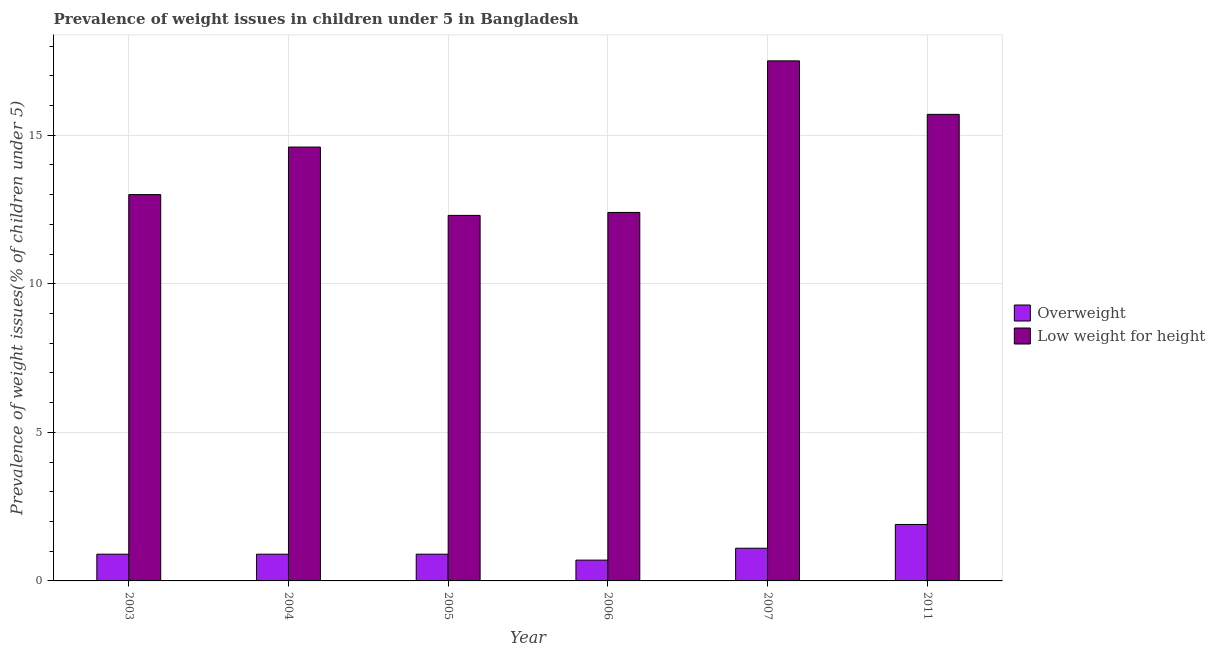How many groups of bars are there?
Offer a terse response. 6. Are the number of bars per tick equal to the number of legend labels?
Ensure brevity in your answer.  Yes. Are the number of bars on each tick of the X-axis equal?
Give a very brief answer. Yes. How many bars are there on the 4th tick from the right?
Your answer should be compact. 2. What is the label of the 2nd group of bars from the left?
Your response must be concise. 2004. In how many cases, is the number of bars for a given year not equal to the number of legend labels?
Provide a succinct answer. 0. What is the percentage of underweight children in 2006?
Make the answer very short. 12.4. Across all years, what is the maximum percentage of underweight children?
Keep it short and to the point. 17.5. Across all years, what is the minimum percentage of underweight children?
Ensure brevity in your answer.  12.3. What is the total percentage of underweight children in the graph?
Provide a short and direct response. 85.5. What is the difference between the percentage of overweight children in 2011 and the percentage of underweight children in 2006?
Your answer should be very brief. 1.2. What is the average percentage of underweight children per year?
Provide a succinct answer. 14.25. What is the ratio of the percentage of underweight children in 2004 to that in 2007?
Give a very brief answer. 0.83. Is the percentage of overweight children in 2004 less than that in 2011?
Provide a short and direct response. Yes. What is the difference between the highest and the second highest percentage of overweight children?
Offer a very short reply. 0.8. What is the difference between the highest and the lowest percentage of underweight children?
Give a very brief answer. 5.2. In how many years, is the percentage of underweight children greater than the average percentage of underweight children taken over all years?
Offer a very short reply. 3. What does the 2nd bar from the left in 2005 represents?
Offer a terse response. Low weight for height. What does the 1st bar from the right in 2006 represents?
Your answer should be very brief. Low weight for height. How many bars are there?
Provide a succinct answer. 12. Are all the bars in the graph horizontal?
Ensure brevity in your answer.  No. How many years are there in the graph?
Give a very brief answer. 6. Does the graph contain grids?
Your answer should be compact. Yes. How many legend labels are there?
Provide a succinct answer. 2. What is the title of the graph?
Your response must be concise. Prevalence of weight issues in children under 5 in Bangladesh. What is the label or title of the Y-axis?
Offer a very short reply. Prevalence of weight issues(% of children under 5). What is the Prevalence of weight issues(% of children under 5) of Overweight in 2003?
Give a very brief answer. 0.9. What is the Prevalence of weight issues(% of children under 5) in Overweight in 2004?
Offer a terse response. 0.9. What is the Prevalence of weight issues(% of children under 5) of Low weight for height in 2004?
Provide a succinct answer. 14.6. What is the Prevalence of weight issues(% of children under 5) in Overweight in 2005?
Offer a terse response. 0.9. What is the Prevalence of weight issues(% of children under 5) of Low weight for height in 2005?
Keep it short and to the point. 12.3. What is the Prevalence of weight issues(% of children under 5) in Overweight in 2006?
Provide a succinct answer. 0.7. What is the Prevalence of weight issues(% of children under 5) in Low weight for height in 2006?
Offer a very short reply. 12.4. What is the Prevalence of weight issues(% of children under 5) in Overweight in 2007?
Give a very brief answer. 1.1. What is the Prevalence of weight issues(% of children under 5) in Overweight in 2011?
Offer a terse response. 1.9. What is the Prevalence of weight issues(% of children under 5) in Low weight for height in 2011?
Make the answer very short. 15.7. Across all years, what is the maximum Prevalence of weight issues(% of children under 5) of Overweight?
Your answer should be very brief. 1.9. Across all years, what is the minimum Prevalence of weight issues(% of children under 5) of Overweight?
Make the answer very short. 0.7. Across all years, what is the minimum Prevalence of weight issues(% of children under 5) in Low weight for height?
Offer a very short reply. 12.3. What is the total Prevalence of weight issues(% of children under 5) in Overweight in the graph?
Your answer should be compact. 6.4. What is the total Prevalence of weight issues(% of children under 5) of Low weight for height in the graph?
Provide a succinct answer. 85.5. What is the difference between the Prevalence of weight issues(% of children under 5) of Low weight for height in 2003 and that in 2004?
Offer a very short reply. -1.6. What is the difference between the Prevalence of weight issues(% of children under 5) of Low weight for height in 2003 and that in 2005?
Offer a very short reply. 0.7. What is the difference between the Prevalence of weight issues(% of children under 5) of Overweight in 2003 and that in 2006?
Your answer should be compact. 0.2. What is the difference between the Prevalence of weight issues(% of children under 5) in Low weight for height in 2003 and that in 2007?
Give a very brief answer. -4.5. What is the difference between the Prevalence of weight issues(% of children under 5) of Overweight in 2003 and that in 2011?
Your answer should be very brief. -1. What is the difference between the Prevalence of weight issues(% of children under 5) of Low weight for height in 2003 and that in 2011?
Give a very brief answer. -2.7. What is the difference between the Prevalence of weight issues(% of children under 5) in Overweight in 2004 and that in 2005?
Keep it short and to the point. 0. What is the difference between the Prevalence of weight issues(% of children under 5) in Low weight for height in 2004 and that in 2005?
Provide a short and direct response. 2.3. What is the difference between the Prevalence of weight issues(% of children under 5) of Overweight in 2004 and that in 2006?
Your answer should be compact. 0.2. What is the difference between the Prevalence of weight issues(% of children under 5) of Overweight in 2004 and that in 2011?
Give a very brief answer. -1. What is the difference between the Prevalence of weight issues(% of children under 5) of Overweight in 2005 and that in 2011?
Your answer should be compact. -1. What is the difference between the Prevalence of weight issues(% of children under 5) in Low weight for height in 2005 and that in 2011?
Your answer should be very brief. -3.4. What is the difference between the Prevalence of weight issues(% of children under 5) of Overweight in 2006 and that in 2007?
Your answer should be compact. -0.4. What is the difference between the Prevalence of weight issues(% of children under 5) in Low weight for height in 2006 and that in 2007?
Offer a terse response. -5.1. What is the difference between the Prevalence of weight issues(% of children under 5) of Low weight for height in 2006 and that in 2011?
Make the answer very short. -3.3. What is the difference between the Prevalence of weight issues(% of children under 5) of Overweight in 2007 and that in 2011?
Provide a succinct answer. -0.8. What is the difference between the Prevalence of weight issues(% of children under 5) in Low weight for height in 2007 and that in 2011?
Give a very brief answer. 1.8. What is the difference between the Prevalence of weight issues(% of children under 5) of Overweight in 2003 and the Prevalence of weight issues(% of children under 5) of Low weight for height in 2004?
Your answer should be very brief. -13.7. What is the difference between the Prevalence of weight issues(% of children under 5) in Overweight in 2003 and the Prevalence of weight issues(% of children under 5) in Low weight for height in 2005?
Your answer should be compact. -11.4. What is the difference between the Prevalence of weight issues(% of children under 5) of Overweight in 2003 and the Prevalence of weight issues(% of children under 5) of Low weight for height in 2007?
Offer a very short reply. -16.6. What is the difference between the Prevalence of weight issues(% of children under 5) in Overweight in 2003 and the Prevalence of weight issues(% of children under 5) in Low weight for height in 2011?
Your response must be concise. -14.8. What is the difference between the Prevalence of weight issues(% of children under 5) in Overweight in 2004 and the Prevalence of weight issues(% of children under 5) in Low weight for height in 2007?
Ensure brevity in your answer.  -16.6. What is the difference between the Prevalence of weight issues(% of children under 5) in Overweight in 2004 and the Prevalence of weight issues(% of children under 5) in Low weight for height in 2011?
Ensure brevity in your answer.  -14.8. What is the difference between the Prevalence of weight issues(% of children under 5) of Overweight in 2005 and the Prevalence of weight issues(% of children under 5) of Low weight for height in 2006?
Offer a terse response. -11.5. What is the difference between the Prevalence of weight issues(% of children under 5) in Overweight in 2005 and the Prevalence of weight issues(% of children under 5) in Low weight for height in 2007?
Give a very brief answer. -16.6. What is the difference between the Prevalence of weight issues(% of children under 5) of Overweight in 2005 and the Prevalence of weight issues(% of children under 5) of Low weight for height in 2011?
Your answer should be compact. -14.8. What is the difference between the Prevalence of weight issues(% of children under 5) in Overweight in 2006 and the Prevalence of weight issues(% of children under 5) in Low weight for height in 2007?
Keep it short and to the point. -16.8. What is the difference between the Prevalence of weight issues(% of children under 5) of Overweight in 2006 and the Prevalence of weight issues(% of children under 5) of Low weight for height in 2011?
Make the answer very short. -15. What is the difference between the Prevalence of weight issues(% of children under 5) of Overweight in 2007 and the Prevalence of weight issues(% of children under 5) of Low weight for height in 2011?
Ensure brevity in your answer.  -14.6. What is the average Prevalence of weight issues(% of children under 5) of Overweight per year?
Provide a succinct answer. 1.07. What is the average Prevalence of weight issues(% of children under 5) of Low weight for height per year?
Your answer should be very brief. 14.25. In the year 2003, what is the difference between the Prevalence of weight issues(% of children under 5) of Overweight and Prevalence of weight issues(% of children under 5) of Low weight for height?
Keep it short and to the point. -12.1. In the year 2004, what is the difference between the Prevalence of weight issues(% of children under 5) of Overweight and Prevalence of weight issues(% of children under 5) of Low weight for height?
Provide a succinct answer. -13.7. In the year 2007, what is the difference between the Prevalence of weight issues(% of children under 5) in Overweight and Prevalence of weight issues(% of children under 5) in Low weight for height?
Provide a succinct answer. -16.4. What is the ratio of the Prevalence of weight issues(% of children under 5) of Overweight in 2003 to that in 2004?
Provide a short and direct response. 1. What is the ratio of the Prevalence of weight issues(% of children under 5) of Low weight for height in 2003 to that in 2004?
Offer a very short reply. 0.89. What is the ratio of the Prevalence of weight issues(% of children under 5) in Overweight in 2003 to that in 2005?
Provide a short and direct response. 1. What is the ratio of the Prevalence of weight issues(% of children under 5) in Low weight for height in 2003 to that in 2005?
Make the answer very short. 1.06. What is the ratio of the Prevalence of weight issues(% of children under 5) in Overweight in 2003 to that in 2006?
Keep it short and to the point. 1.29. What is the ratio of the Prevalence of weight issues(% of children under 5) in Low weight for height in 2003 to that in 2006?
Keep it short and to the point. 1.05. What is the ratio of the Prevalence of weight issues(% of children under 5) of Overweight in 2003 to that in 2007?
Provide a short and direct response. 0.82. What is the ratio of the Prevalence of weight issues(% of children under 5) in Low weight for height in 2003 to that in 2007?
Give a very brief answer. 0.74. What is the ratio of the Prevalence of weight issues(% of children under 5) of Overweight in 2003 to that in 2011?
Keep it short and to the point. 0.47. What is the ratio of the Prevalence of weight issues(% of children under 5) in Low weight for height in 2003 to that in 2011?
Your answer should be compact. 0.83. What is the ratio of the Prevalence of weight issues(% of children under 5) in Low weight for height in 2004 to that in 2005?
Your answer should be very brief. 1.19. What is the ratio of the Prevalence of weight issues(% of children under 5) of Overweight in 2004 to that in 2006?
Provide a short and direct response. 1.29. What is the ratio of the Prevalence of weight issues(% of children under 5) of Low weight for height in 2004 to that in 2006?
Provide a short and direct response. 1.18. What is the ratio of the Prevalence of weight issues(% of children under 5) in Overweight in 2004 to that in 2007?
Offer a terse response. 0.82. What is the ratio of the Prevalence of weight issues(% of children under 5) in Low weight for height in 2004 to that in 2007?
Ensure brevity in your answer.  0.83. What is the ratio of the Prevalence of weight issues(% of children under 5) of Overweight in 2004 to that in 2011?
Give a very brief answer. 0.47. What is the ratio of the Prevalence of weight issues(% of children under 5) of Low weight for height in 2004 to that in 2011?
Ensure brevity in your answer.  0.93. What is the ratio of the Prevalence of weight issues(% of children under 5) in Overweight in 2005 to that in 2006?
Your answer should be compact. 1.29. What is the ratio of the Prevalence of weight issues(% of children under 5) of Low weight for height in 2005 to that in 2006?
Give a very brief answer. 0.99. What is the ratio of the Prevalence of weight issues(% of children under 5) in Overweight in 2005 to that in 2007?
Ensure brevity in your answer.  0.82. What is the ratio of the Prevalence of weight issues(% of children under 5) in Low weight for height in 2005 to that in 2007?
Give a very brief answer. 0.7. What is the ratio of the Prevalence of weight issues(% of children under 5) in Overweight in 2005 to that in 2011?
Your response must be concise. 0.47. What is the ratio of the Prevalence of weight issues(% of children under 5) in Low weight for height in 2005 to that in 2011?
Keep it short and to the point. 0.78. What is the ratio of the Prevalence of weight issues(% of children under 5) of Overweight in 2006 to that in 2007?
Offer a very short reply. 0.64. What is the ratio of the Prevalence of weight issues(% of children under 5) in Low weight for height in 2006 to that in 2007?
Your answer should be very brief. 0.71. What is the ratio of the Prevalence of weight issues(% of children under 5) of Overweight in 2006 to that in 2011?
Provide a succinct answer. 0.37. What is the ratio of the Prevalence of weight issues(% of children under 5) in Low weight for height in 2006 to that in 2011?
Give a very brief answer. 0.79. What is the ratio of the Prevalence of weight issues(% of children under 5) of Overweight in 2007 to that in 2011?
Provide a succinct answer. 0.58. What is the ratio of the Prevalence of weight issues(% of children under 5) in Low weight for height in 2007 to that in 2011?
Ensure brevity in your answer.  1.11. What is the difference between the highest and the lowest Prevalence of weight issues(% of children under 5) in Overweight?
Offer a very short reply. 1.2. 